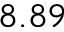<formula> <loc_0><loc_0><loc_500><loc_500>8 . 8 9</formula> 